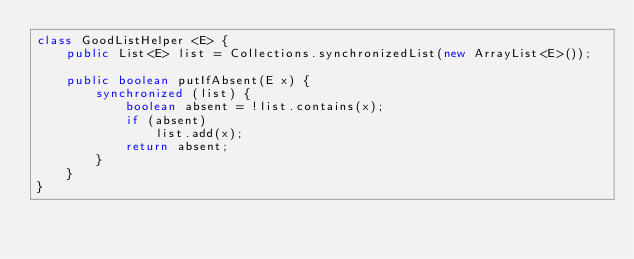<code> <loc_0><loc_0><loc_500><loc_500><_Java_>class GoodListHelper <E> {
    public List<E> list = Collections.synchronizedList(new ArrayList<E>());

    public boolean putIfAbsent(E x) {
        synchronized (list) {
            boolean absent = !list.contains(x);
            if (absent)
                list.add(x);
            return absent;
        }
    }
}
</code> 